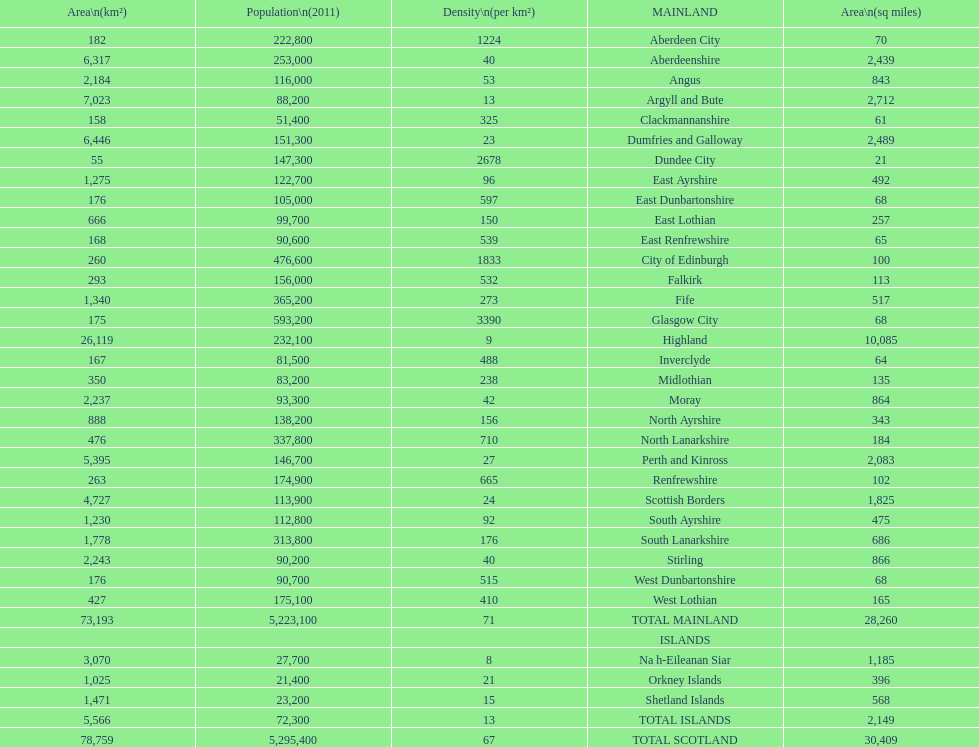What is the total area of east lothian, angus, and dundee city? 1121. 